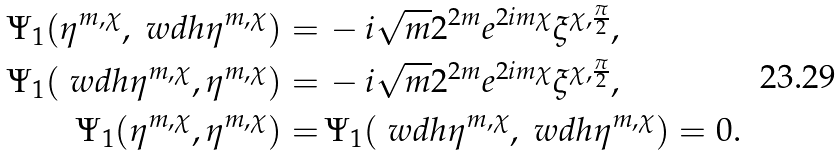Convert formula to latex. <formula><loc_0><loc_0><loc_500><loc_500>\Psi _ { 1 } ( \eta ^ { m , \chi } , \ w d h { \eta } ^ { m , \chi } ) = & \, - i \sqrt { m } 2 ^ { 2 m } e ^ { 2 i m \chi } \xi ^ { \chi , \frac { \pi } { 2 } } , \\ \Psi _ { 1 } ( \ w d h { \eta } ^ { m , \chi } , \eta ^ { m , \chi } ) = & \, - i \sqrt { m } 2 ^ { 2 m } e ^ { 2 i m \chi } \xi ^ { \chi , \frac { \pi } { 2 } } , \\ \Psi _ { 1 } ( \eta ^ { m , \chi } , \eta ^ { m , \chi } ) = & \, \Psi _ { 1 } ( \ w d h { \eta } ^ { m , \chi } , \ w d h { \eta } ^ { m , \chi } ) = 0 .</formula> 